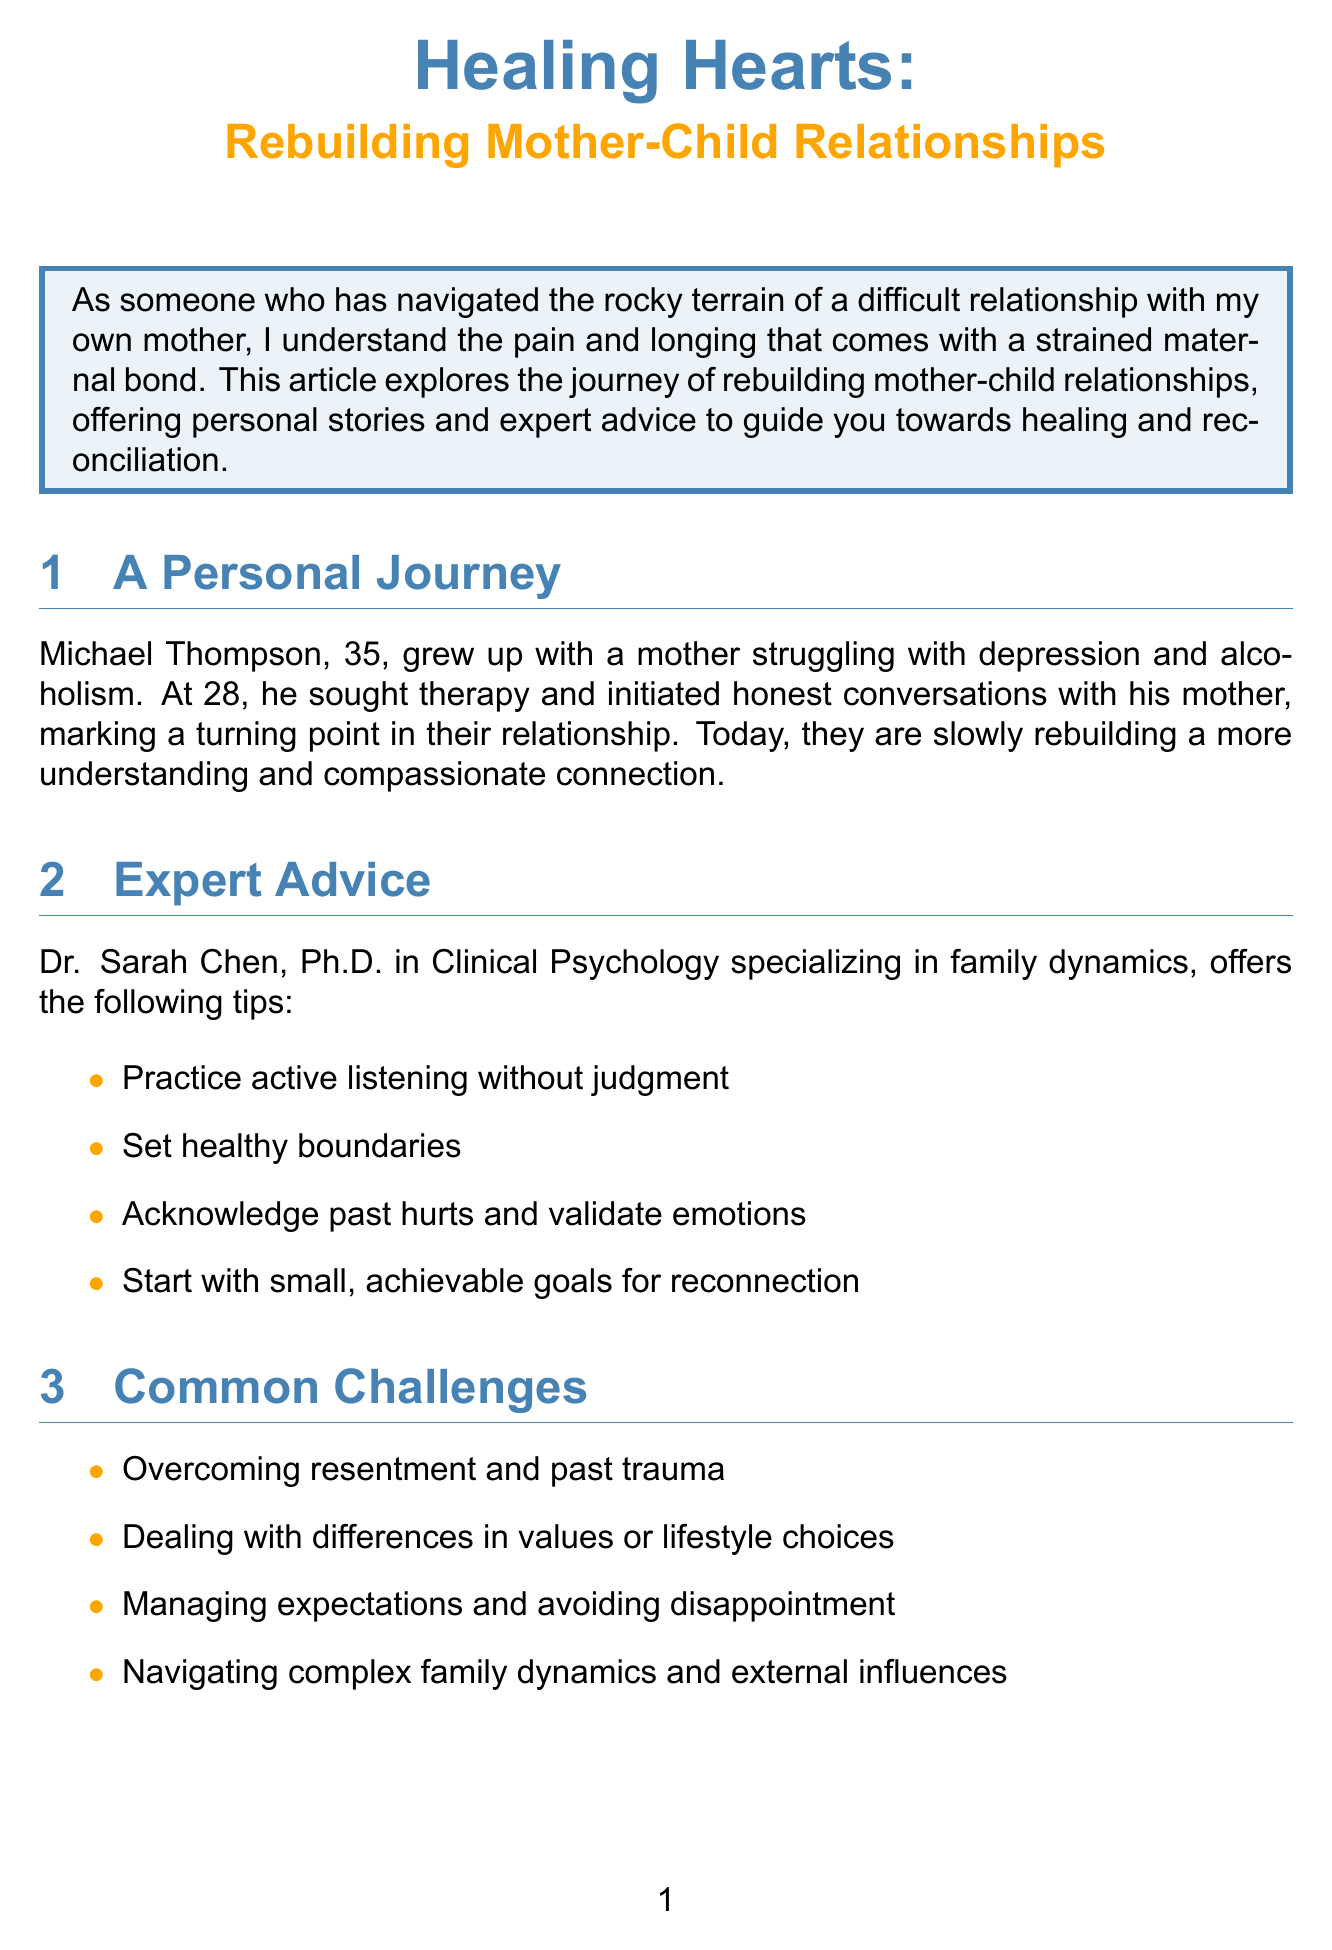What is the title of the article? The title is explicitly stated at the beginning of the document.
Answer: Healing Hearts: Rebuilding Mother-Child Relationships Who shares a personal story in the article? The document mentions a specific individual sharing their experience.
Answer: Michael Thompson What is one of the challenges mentioned in the article? The document lists challenges under a specific section.
Answer: Overcoming resentment and past trauma What is Dr. Sarah Chen's area of specialization? The document provides her credentials related to family issues.
Answer: Family dynamics How old is Michael Thompson? The document includes the age of the individual sharing their story.
Answer: 35 What healing strategy involves writing? The document includes various strategies with descriptions.
Answer: Letter writing What type of resource is "The Reconciliation Project"? The document classifies resources into different types.
Answer: Support group What is the call to action at the end of the article? The conclusion section emphasizes a specific action for readers.
Answer: Take the first step towards healing today by reaching out or seeking professional support What is one tip given by Dr. Sarah Chen? The advice section lists strategies provided by the expert.
Answer: Practice active listening without judgment 